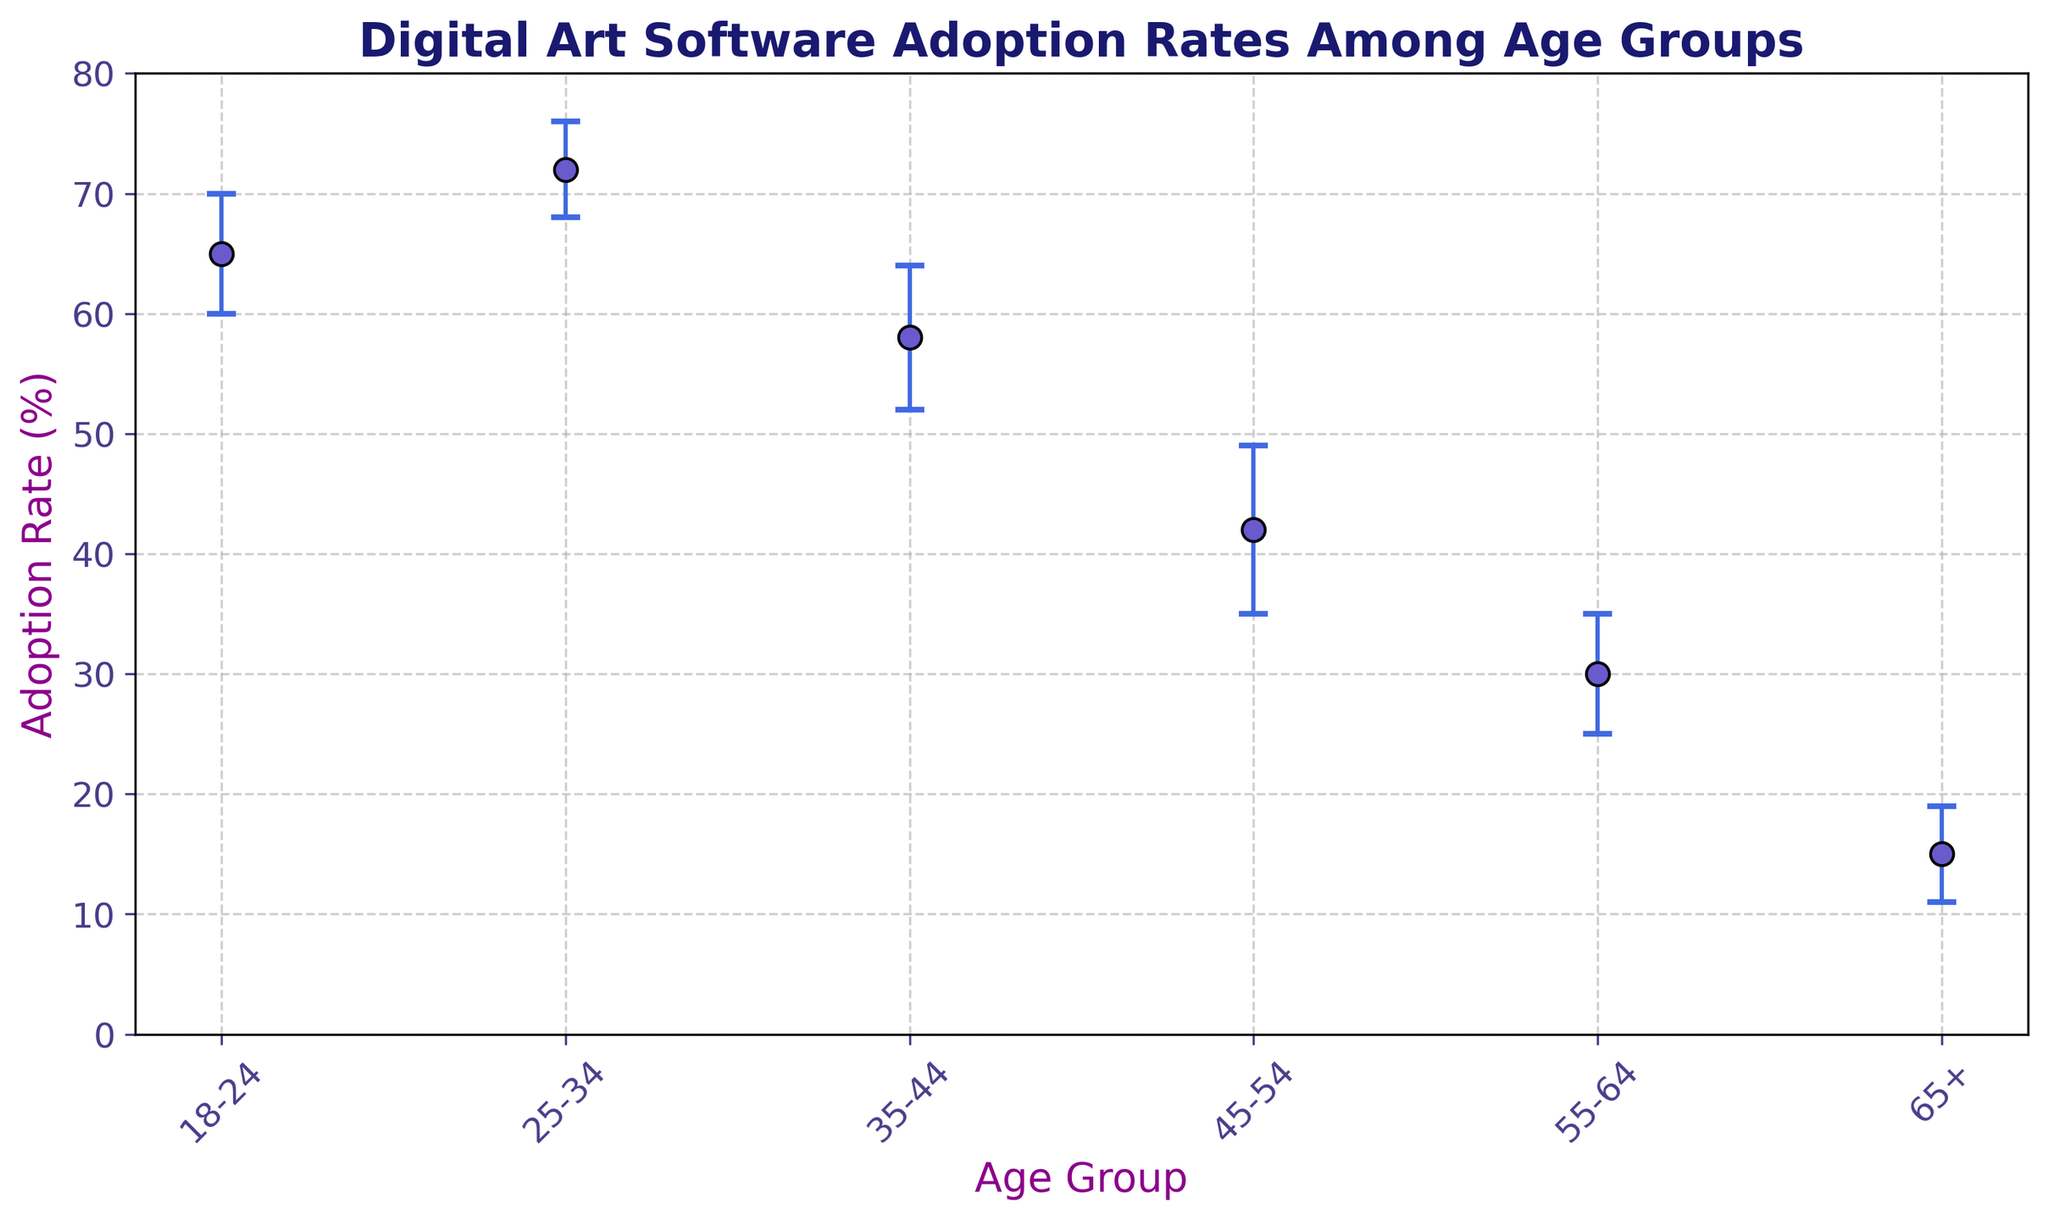Which age group has the highest digital art software adoption rate? The figure shows that the age group 25-34 has the highest point of adoption rate.
Answer: 25-34 By how many percentage points does the adoption rate of the age group 25-34 exceed that of the age group 45-54? The adoption rate for 25-34 is 72%, and for 45-54 is 42%. Subtracting 42 from 72 gives 30 percentage points.
Answer: 30 What is the average adoption rate of the age groups 18-24, 25-34, and 35-44? The adoption rates are 65%, 72%, and 58% respectively. Adding them together gives 195. Dividing by 3 (number of age groups) results in an average adoption rate of 65%.
Answer: 65 Which age group has the largest error margin in its survey responses? By visually inspecting the size of the error bars, the age group 45-54 has the largest error margin of 7 percentage points.
Answer: 45-54 What is the difference in adoption rates between the oldest and the youngest age groups? The adoption rate for 65+ is 15%, and for 18-24 is 65%. Subtracting 15 from 65 results in a difference of 50 percentage points.
Answer: 50 Compare the adoption rates of the age groups 35-44 and 55-64. Which group has a higher rate, and by how much? The adoption rate for 35-44 is 58%, and for 55-64 is 30%. Subtracting 30 from 58 gives a difference of 28 percentage points, with 35-44 being higher.
Answer: 35-44, 28 What is the range of adoption rates observed among all age groups? The highest adoption rate is 72% (25-34) and the lowest is 15% (65+). Subtracting 15 from 72 gives a range of 57 percentage points.
Answer: 57 